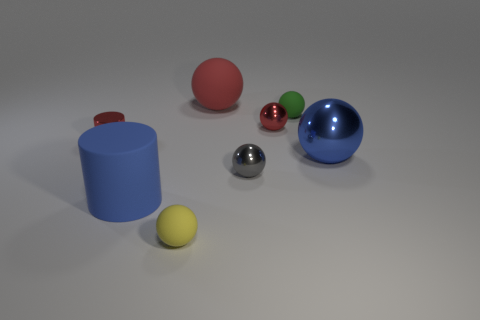There is a sphere that is the same color as the big matte cylinder; what is its size?
Provide a short and direct response. Large. How many other objects are there of the same size as the yellow thing?
Your answer should be compact. 4. Does the small shiny cylinder have the same color as the matte cylinder?
Make the answer very short. No. Do the small matte thing that is left of the tiny red sphere and the small gray metallic thing have the same shape?
Give a very brief answer. Yes. What number of tiny balls are in front of the small cylinder and on the right side of the big red rubber thing?
Your answer should be compact. 1. What is the small yellow object made of?
Give a very brief answer. Rubber. Are there any other things that are the same color as the small shiny cylinder?
Provide a short and direct response. Yes. Do the yellow object and the big red sphere have the same material?
Provide a short and direct response. Yes. What number of large blue things are behind the matte thing on the left side of the small rubber object that is in front of the small red metal ball?
Provide a succinct answer. 1. How many rubber balls are there?
Your response must be concise. 3. 